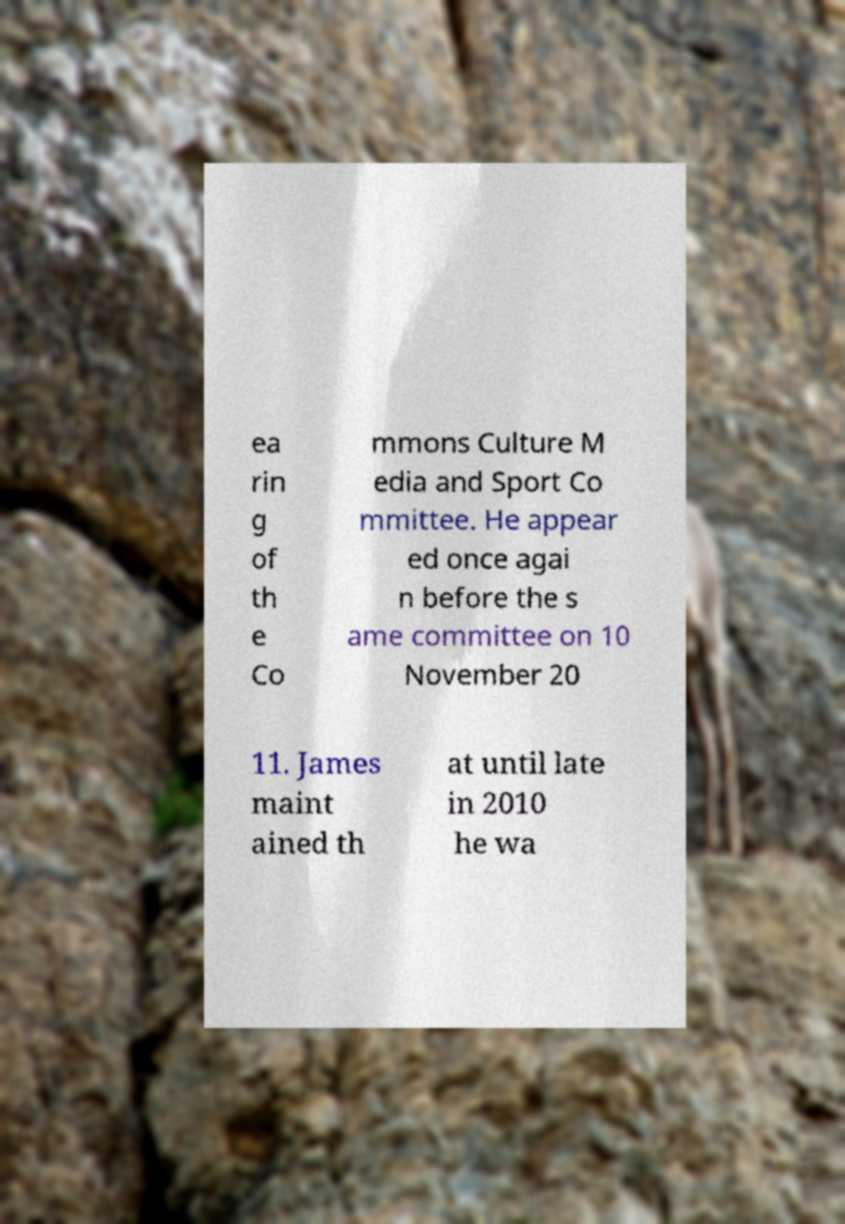Could you extract and type out the text from this image? ea rin g of th e Co mmons Culture M edia and Sport Co mmittee. He appear ed once agai n before the s ame committee on 10 November 20 11. James maint ained th at until late in 2010 he wa 